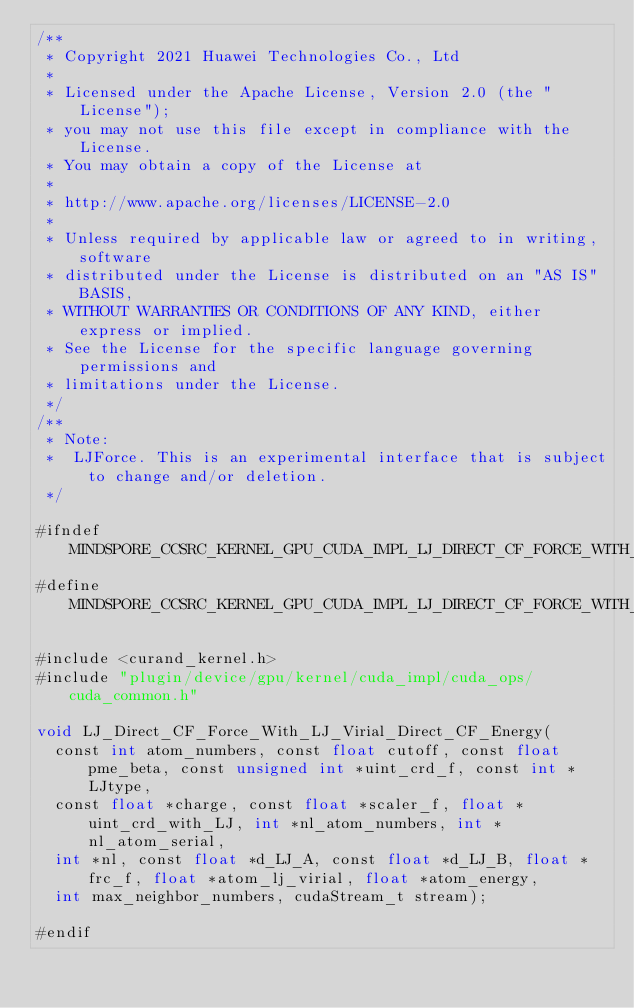<code> <loc_0><loc_0><loc_500><loc_500><_Cuda_>/**
 * Copyright 2021 Huawei Technologies Co., Ltd
 *
 * Licensed under the Apache License, Version 2.0 (the "License");
 * you may not use this file except in compliance with the License.
 * You may obtain a copy of the License at
 *
 * http://www.apache.org/licenses/LICENSE-2.0
 *
 * Unless required by applicable law or agreed to in writing, software
 * distributed under the License is distributed on an "AS IS" BASIS,
 * WITHOUT WARRANTIES OR CONDITIONS OF ANY KIND, either express or implied.
 * See the License for the specific language governing permissions and
 * limitations under the License.
 */
/**
 * Note:
 *  LJForce. This is an experimental interface that is subject to change and/or deletion.
 */

#ifndef MINDSPORE_CCSRC_KERNEL_GPU_CUDA_IMPL_LJ_DIRECT_CF_FORCE_WITH_LJ_VIRIAL_DIRECT_CF_ENERGY_IMPL_H_
#define MINDSPORE_CCSRC_KERNEL_GPU_CUDA_IMPL_LJ_DIRECT_CF_FORCE_WITH_LJ_VIRIAL_DIRECT_CF_ENERGY_IMPL_H_

#include <curand_kernel.h>
#include "plugin/device/gpu/kernel/cuda_impl/cuda_ops/cuda_common.h"

void LJ_Direct_CF_Force_With_LJ_Virial_Direct_CF_Energy(
  const int atom_numbers, const float cutoff, const float pme_beta, const unsigned int *uint_crd_f, const int *LJtype,
  const float *charge, const float *scaler_f, float *uint_crd_with_LJ, int *nl_atom_numbers, int *nl_atom_serial,
  int *nl, const float *d_LJ_A, const float *d_LJ_B, float *frc_f, float *atom_lj_virial, float *atom_energy,
  int max_neighbor_numbers, cudaStream_t stream);

#endif
</code> 